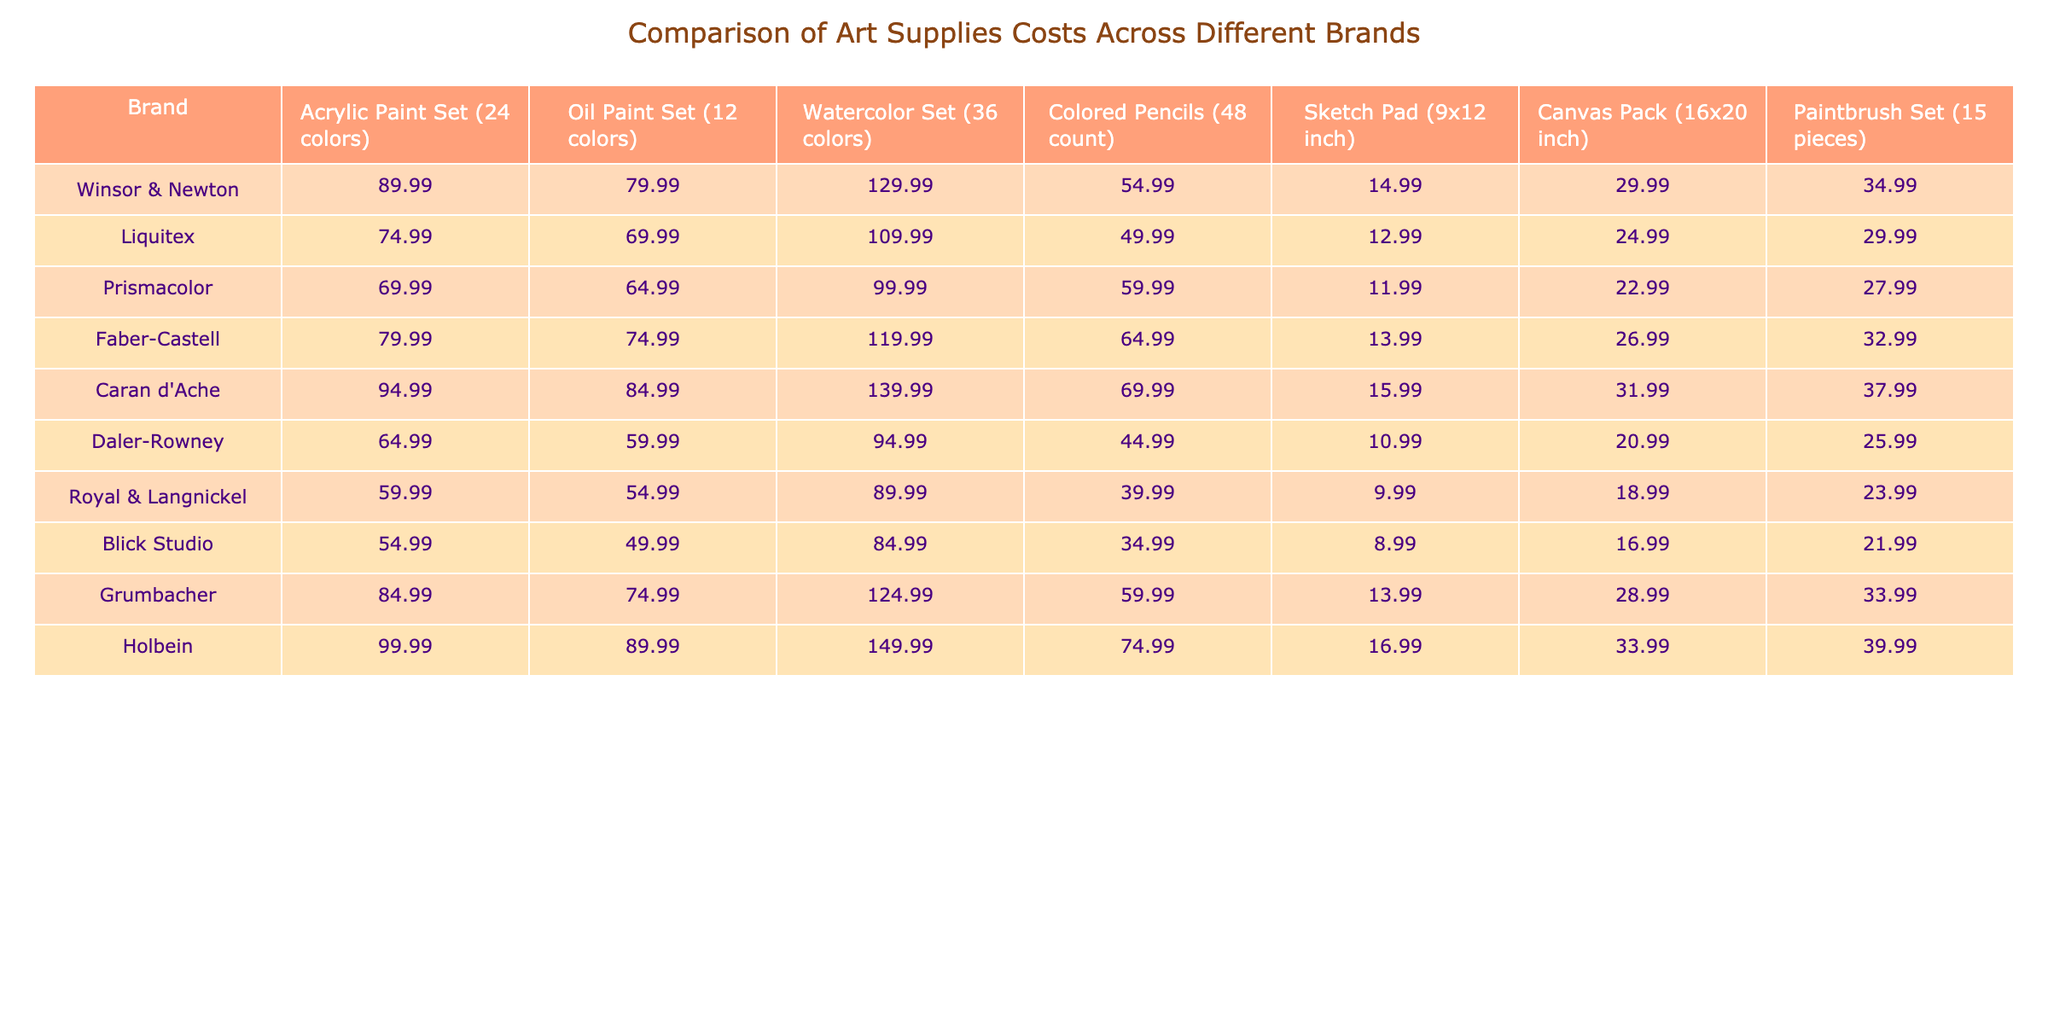What is the cost of the Acrylic Paint Set from Winsor & Newton? The table shows the cost of the Acrylic Paint Set from Winsor & Newton is 89.99.
Answer: 89.99 Which brand offers the cheapest Watercolor Set? By comparing the prices in the Watercolor Set column, Royal & Langnickel has the lowest price at 89.99.
Answer: Royal & Langnickel What is the difference in price between the most expensive and the least expensive Sketch Pad? The most expensive Sketch Pad is from Holbein at 16.99 and the least expensive is from Blick Studio at 8.99. The difference is 16.99 - 8.99 = 8.00.
Answer: 8.00 Which brand offers the most expensive Oil Paint Set? The Oil Paint Set from Holbein is priced at 89.99, which is the highest among the listed brands.
Answer: Holbein What is the average cost of the Colored Pencils across all brands? To find the average, sum the prices (54.99 + 49.99 + 59.99 + 64.99 + 69.99 + 44.99 + 39.99 + 34.99 + 59.99 + 74.99) which equals 514.90, then divide by the number of brands (10), resulting in an average of 51.49.
Answer: 51.49 Is the cost of Faber-Castell’s Acrylic Paint Set higher than that of Prismacolor’s? Faber-Castell's Acrylic Paint Set costs 79.99 and Prismacolor's costs 69.99; since 79.99 > 69.99, the statement is true.
Answer: Yes What is the total cost of purchasing one item from each category of Blick Studio? The total is calculated as follows: Acrylic Paint Set (54.99) + Oil Paint Set (49.99) + Watercolor Set (84.99) + Colored Pencils (34.99) + Sketch Pad (8.99) + Canvas Pack (16.99) + Paintbrush Set (21.99) = 272.93.
Answer: 272.93 Which brand has the lowest overall average cost across all categories of art supplies? Calculate the average for each brand: 
- Winsor & Newton: (89.99 + 79.99 + 129.99 + 54.99 + 14.99 + 29.99 + 34.99) / 7 = 58.84 
- Liquitex: (74.99 + 69.99 + 109.99 + 49.99 + 12.99 + 24.99 + 29.99) / 7 = 32.14 
Continuing this way, you find that Blick Studio has the lowest average cost.
Answer: Blick Studio What percentage more does the most expensive Acrylic Paint Set cost compared to the least expensive? The most expensive is Holbein at 99.99 and the least expensive is Blick Studio at 54.99. The difference is 99.99 - 54.99 = 45.00. The percentage more is (45.00 / 54.99) * 100 ≈ 81.74%.
Answer: 81.74% Is there any brand that has a Sketch Pad costing less than 10? By reviewing the Sketch Pad prices, the lowest is 8.99 from Blick Studio, which is indeed less than 10, confirming the statement is true.
Answer: Yes 